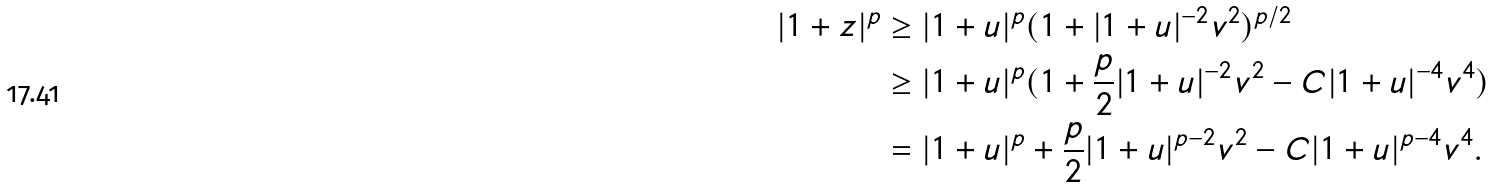<formula> <loc_0><loc_0><loc_500><loc_500>| 1 + z | ^ { p } & \geq | 1 + u | ^ { p } ( 1 + | 1 + u | ^ { - 2 } v ^ { 2 } ) ^ { p / 2 } \\ & \geq | 1 + u | ^ { p } ( 1 + \frac { p } 2 | 1 + u | ^ { - 2 } v ^ { 2 } - C | 1 + u | ^ { - 4 } v ^ { 4 } ) \\ & = | 1 + u | ^ { p } + \frac { p } 2 | 1 + u | ^ { p - 2 } v ^ { 2 } - C | 1 + u | ^ { p - 4 } v ^ { 4 } .</formula> 